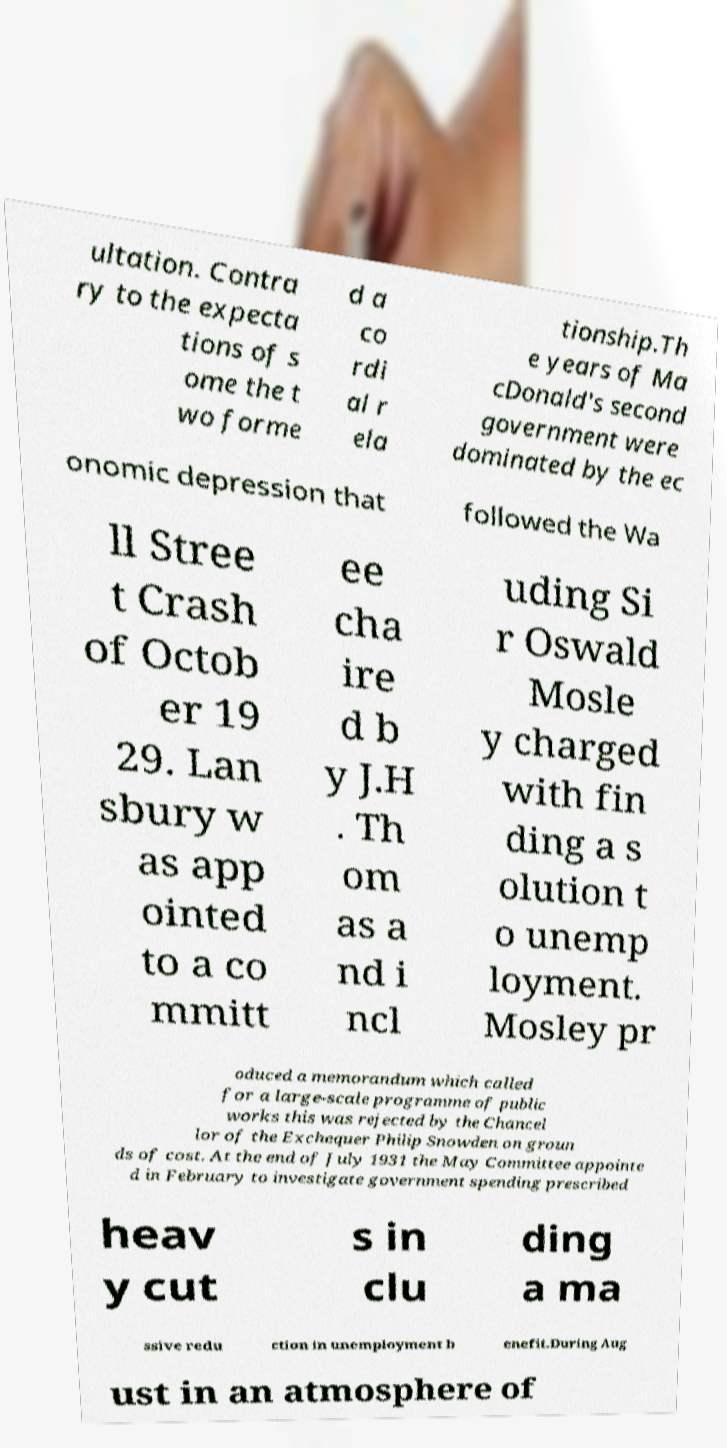Could you assist in decoding the text presented in this image and type it out clearly? ultation. Contra ry to the expecta tions of s ome the t wo forme d a co rdi al r ela tionship.Th e years of Ma cDonald's second government were dominated by the ec onomic depression that followed the Wa ll Stree t Crash of Octob er 19 29. Lan sbury w as app ointed to a co mmitt ee cha ire d b y J.H . Th om as a nd i ncl uding Si r Oswald Mosle y charged with fin ding a s olution t o unemp loyment. Mosley pr oduced a memorandum which called for a large-scale programme of public works this was rejected by the Chancel lor of the Exchequer Philip Snowden on groun ds of cost. At the end of July 1931 the May Committee appointe d in February to investigate government spending prescribed heav y cut s in clu ding a ma ssive redu ction in unemployment b enefit.During Aug ust in an atmosphere of 